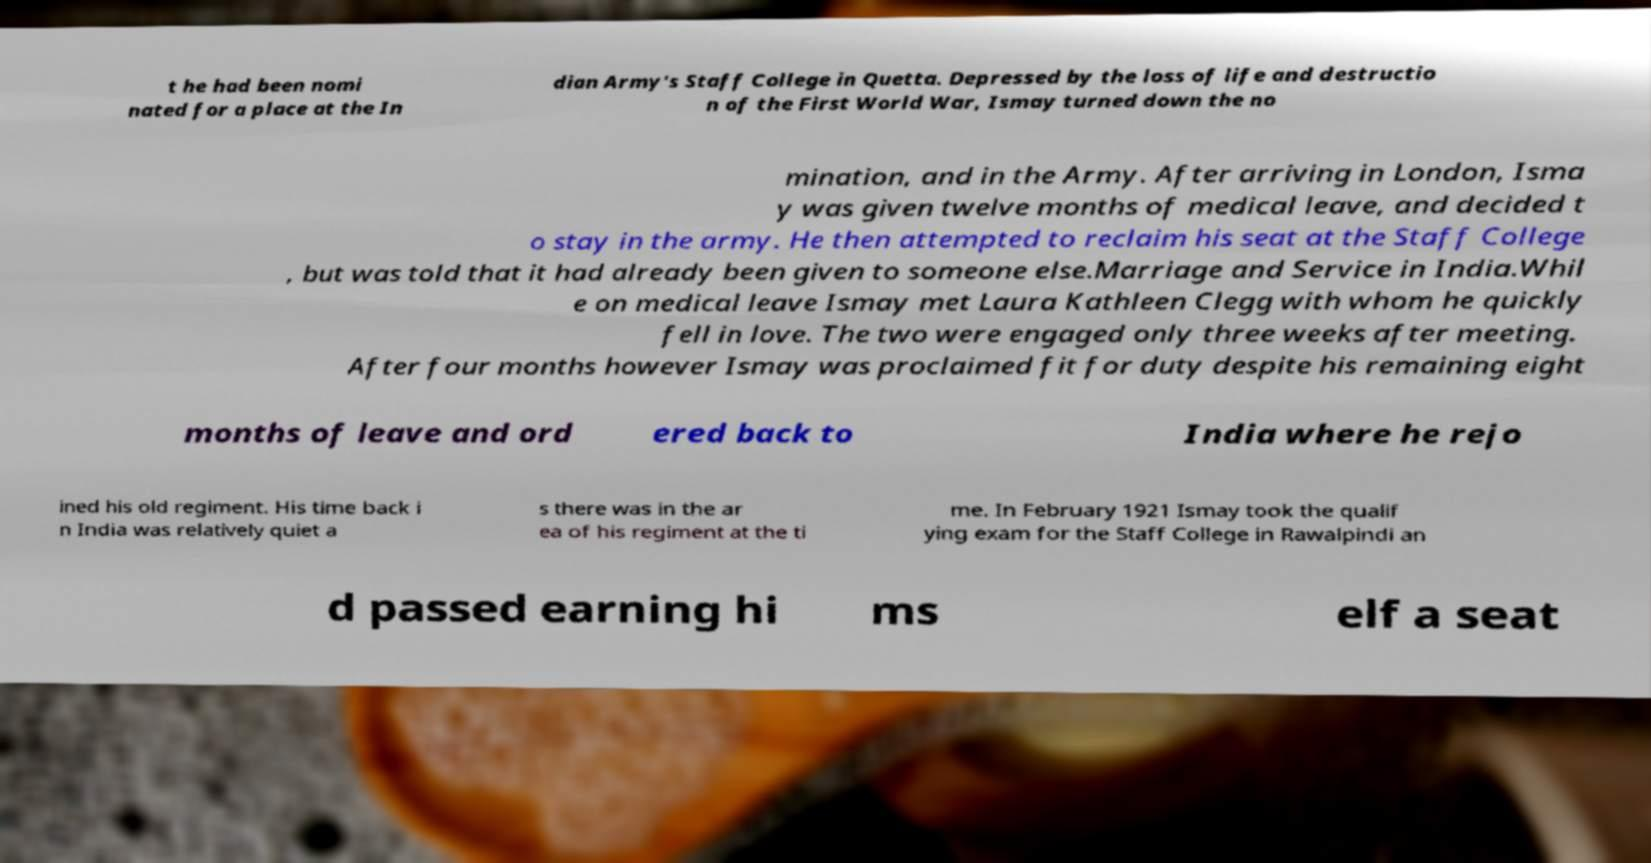Please identify and transcribe the text found in this image. t he had been nomi nated for a place at the In dian Army's Staff College in Quetta. Depressed by the loss of life and destructio n of the First World War, Ismay turned down the no mination, and in the Army. After arriving in London, Isma y was given twelve months of medical leave, and decided t o stay in the army. He then attempted to reclaim his seat at the Staff College , but was told that it had already been given to someone else.Marriage and Service in India.Whil e on medical leave Ismay met Laura Kathleen Clegg with whom he quickly fell in love. The two were engaged only three weeks after meeting. After four months however Ismay was proclaimed fit for duty despite his remaining eight months of leave and ord ered back to India where he rejo ined his old regiment. His time back i n India was relatively quiet a s there was in the ar ea of his regiment at the ti me. In February 1921 Ismay took the qualif ying exam for the Staff College in Rawalpindi an d passed earning hi ms elf a seat 